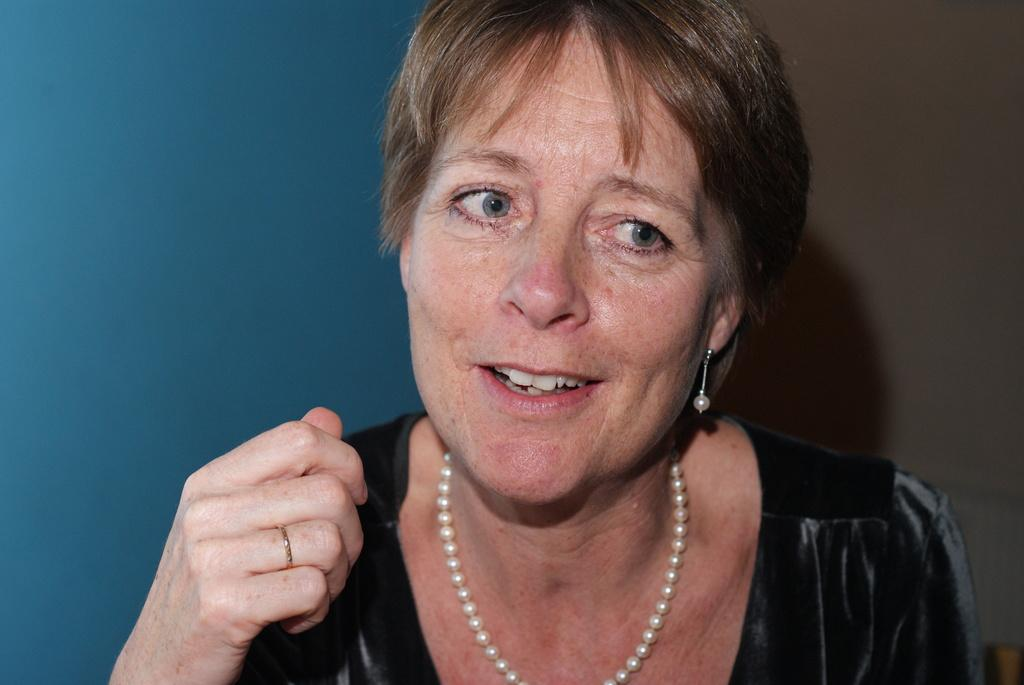Who is present in the image? There is a woman in the image. What is the woman doing in the image? The woman is smiling in the image. What type of jewelry is the woman wearing? The woman is wearing pearls jewelry in the image. Can you describe any other accessory the woman is wearing? There is a ring on the woman's finger in the image. What colors can be seen in the background of the image? The background of the image includes blue and ash colors. What type of rifle is the woman holding in the image? There is no rifle present in the image; the woman is not holding any weapon. What historical event is depicted in the image? The image does not depict any historical event; it features a woman smiling and wearing jewelry. 